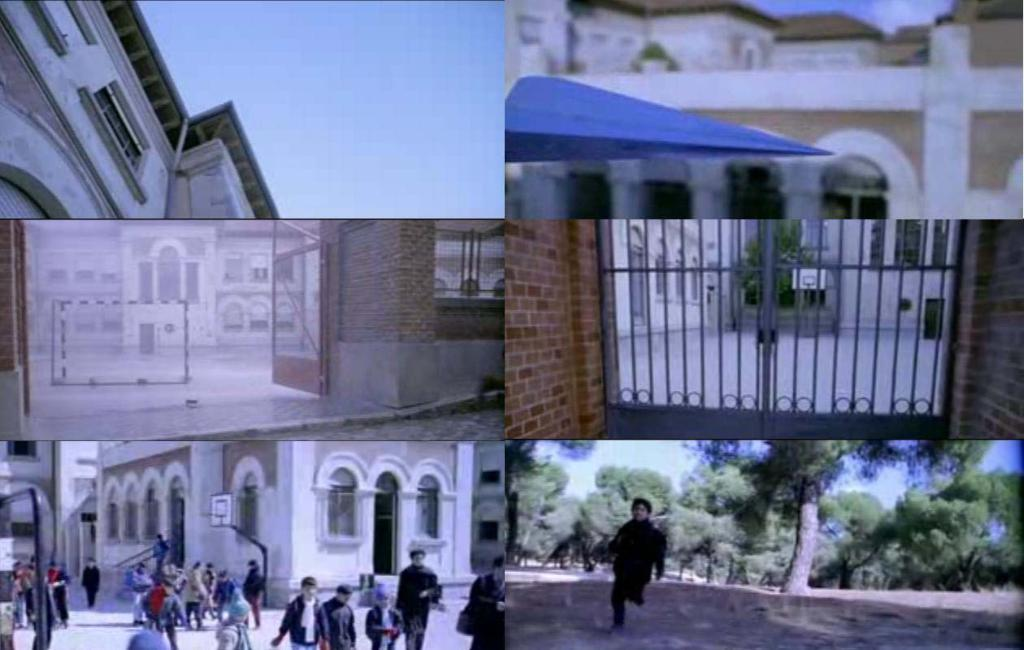What is happening on the road in the image? There is a crowd on the road in the image. What type of vegetation can be seen in the image? There are trees in the image. What is separating the crowd from the trees? There is a fence in the image. What type of structures are visible in the image? There are buildings in the image. What is visible above the crowd and buildings? The sky is visible in the image. What type of cheese is being used to build the fence in the image? There is no cheese present in the image, and the fence is not made of cheese. Can you see a beetle crawling on the crowd in the image? There is no beetle visible in the image; only the crowd, trees, fence, buildings, and sky are present. 